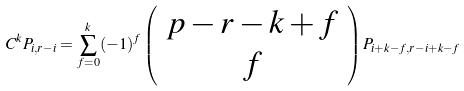Convert formula to latex. <formula><loc_0><loc_0><loc_500><loc_500>C ^ { k } P _ { i , r - i } = \sum _ { f = 0 } ^ { k } ( - 1 ) ^ { f } \left ( \begin{array} { c } p - r - k + f \\ f \end{array} \right ) P _ { i + k - f , r - i + k - f }</formula> 